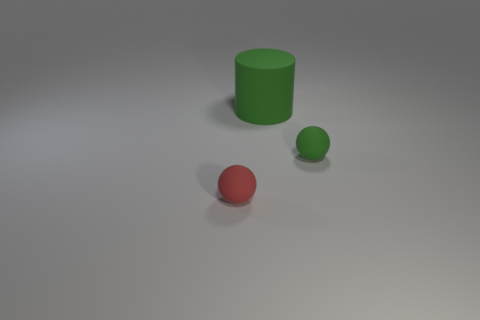The ball that is the same material as the tiny green thing is what color?
Offer a terse response. Red. How many shiny objects are either small green cubes or green balls?
Your response must be concise. 0. How many objects are either rubber objects that are behind the red object or rubber spheres that are behind the red thing?
Give a very brief answer. 2. There is another sphere that is the same size as the red sphere; what is its material?
Your response must be concise. Rubber. Are there the same number of matte objects that are behind the green matte cylinder and spheres that are left of the tiny green ball?
Keep it short and to the point. No. How many purple objects are spheres or rubber cubes?
Provide a short and direct response. 0. Do the large rubber cylinder and the ball right of the large cylinder have the same color?
Provide a succinct answer. Yes. How many other things are there of the same color as the large object?
Your response must be concise. 1. Is the number of big green shiny cubes less than the number of small green objects?
Offer a terse response. Yes. There is a tiny ball on the left side of the ball that is to the right of the red sphere; how many rubber things are behind it?
Your response must be concise. 2. 